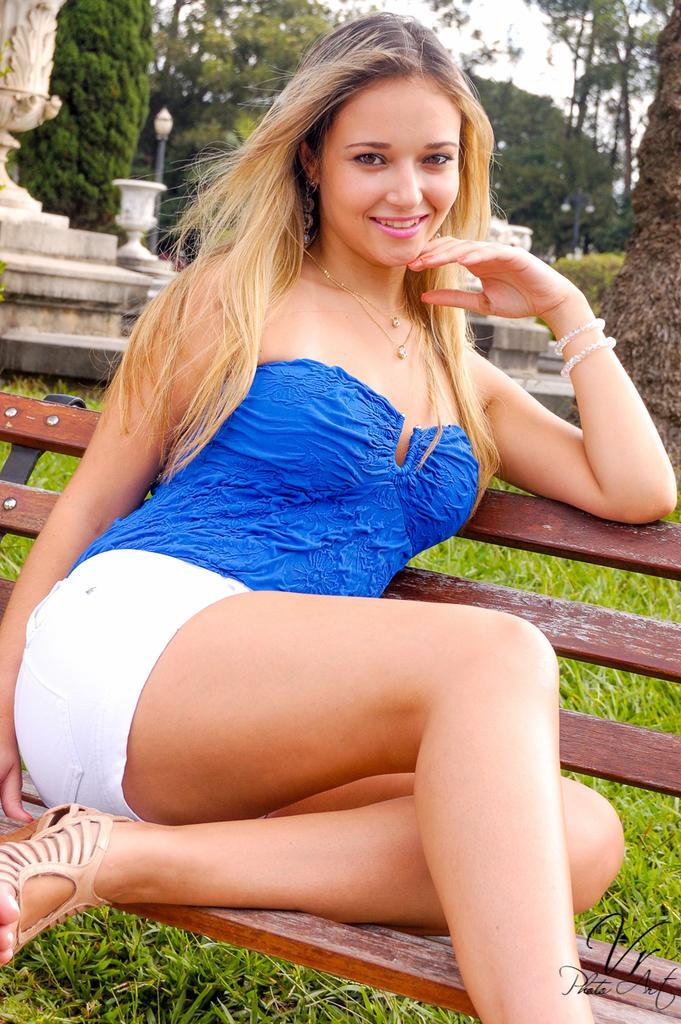In one or two sentences, can you explain what this image depicts? In this image I can see a woman wearing blue and white colored dress is sitting on a bench. I can see the grass, few trees, a pole and in the background I can see the sky. 